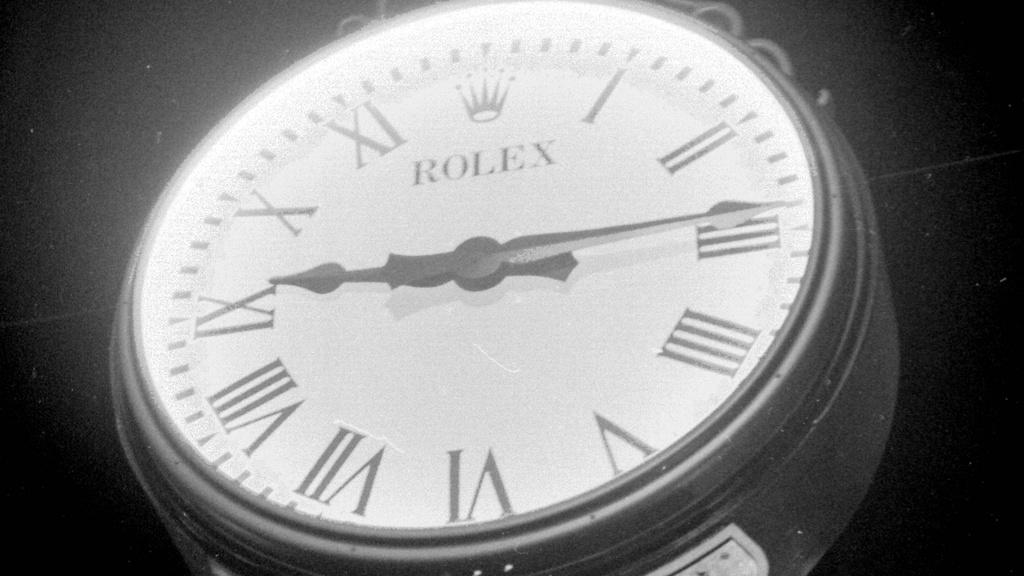Provide a one-sentence caption for the provided image. Face of a Rolex watch with the hands at 9 and 3. 